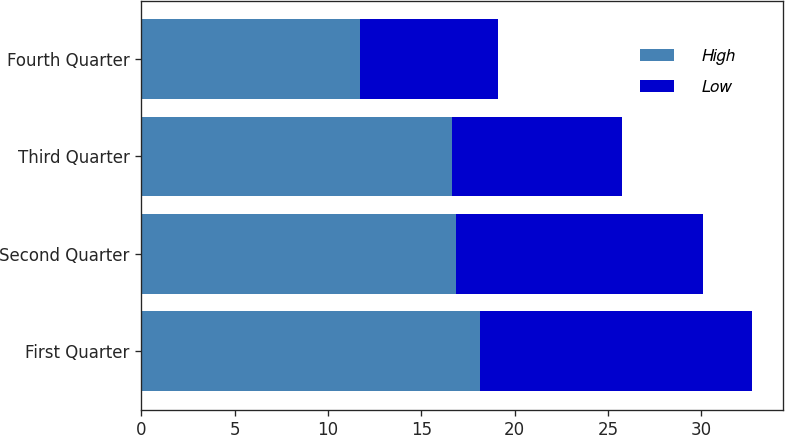<chart> <loc_0><loc_0><loc_500><loc_500><stacked_bar_chart><ecel><fcel>First Quarter<fcel>Second Quarter<fcel>Third Quarter<fcel>Fourth Quarter<nl><fcel>High<fcel>18.13<fcel>16.83<fcel>16.66<fcel>11.69<nl><fcel>Low<fcel>14.6<fcel>13.23<fcel>9.07<fcel>7.42<nl></chart> 